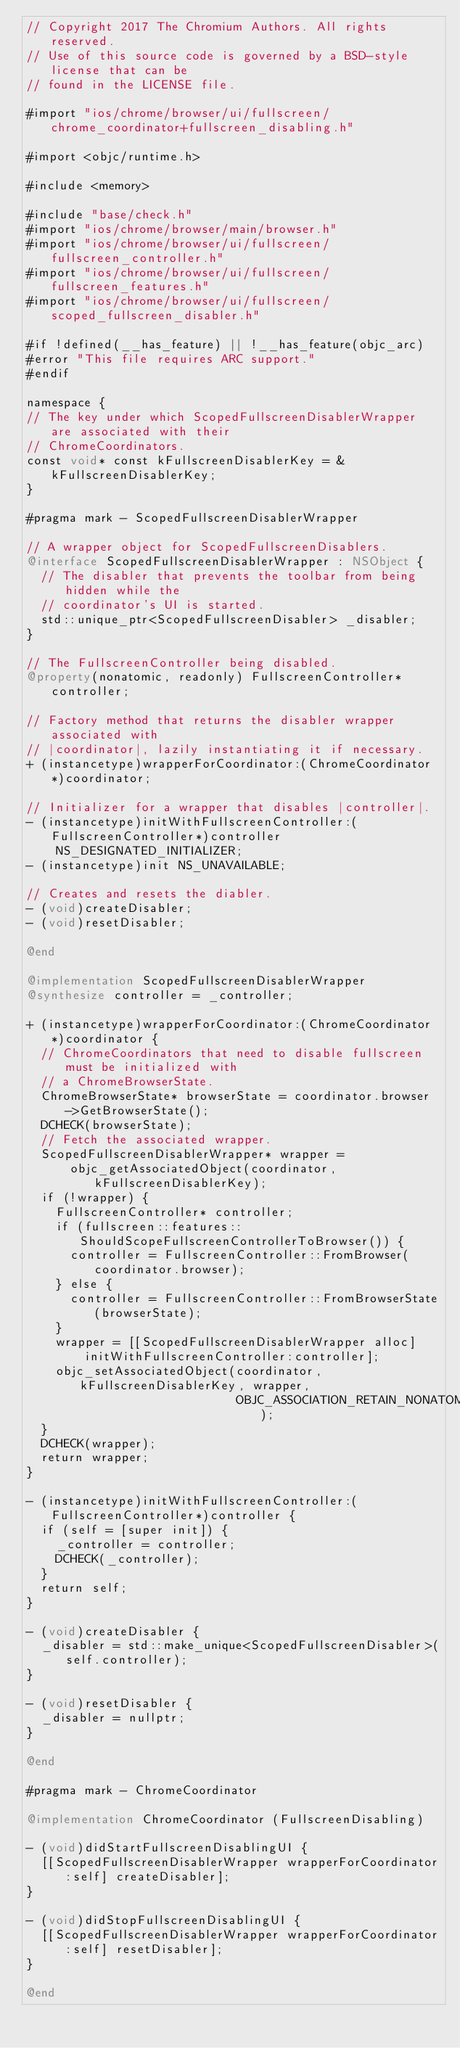Convert code to text. <code><loc_0><loc_0><loc_500><loc_500><_ObjectiveC_>// Copyright 2017 The Chromium Authors. All rights reserved.
// Use of this source code is governed by a BSD-style license that can be
// found in the LICENSE file.

#import "ios/chrome/browser/ui/fullscreen/chrome_coordinator+fullscreen_disabling.h"

#import <objc/runtime.h>

#include <memory>

#include "base/check.h"
#import "ios/chrome/browser/main/browser.h"
#import "ios/chrome/browser/ui/fullscreen/fullscreen_controller.h"
#import "ios/chrome/browser/ui/fullscreen/fullscreen_features.h"
#import "ios/chrome/browser/ui/fullscreen/scoped_fullscreen_disabler.h"

#if !defined(__has_feature) || !__has_feature(objc_arc)
#error "This file requires ARC support."
#endif

namespace {
// The key under which ScopedFullscreenDisablerWrapper are associated with their
// ChromeCoordinators.
const void* const kFullscreenDisablerKey = &kFullscreenDisablerKey;
}

#pragma mark - ScopedFullscreenDisablerWrapper

// A wrapper object for ScopedFullscreenDisablers.
@interface ScopedFullscreenDisablerWrapper : NSObject {
  // The disabler that prevents the toolbar from being hidden while the
  // coordinator's UI is started.
  std::unique_ptr<ScopedFullscreenDisabler> _disabler;
}

// The FullscreenController being disabled.
@property(nonatomic, readonly) FullscreenController* controller;

// Factory method that returns the disabler wrapper associated with
// |coordinator|, lazily instantiating it if necessary.
+ (instancetype)wrapperForCoordinator:(ChromeCoordinator*)coordinator;

// Initializer for a wrapper that disables |controller|.
- (instancetype)initWithFullscreenController:(FullscreenController*)controller
    NS_DESIGNATED_INITIALIZER;
- (instancetype)init NS_UNAVAILABLE;

// Creates and resets the diabler.
- (void)createDisabler;
- (void)resetDisabler;

@end

@implementation ScopedFullscreenDisablerWrapper
@synthesize controller = _controller;

+ (instancetype)wrapperForCoordinator:(ChromeCoordinator*)coordinator {
  // ChromeCoordinators that need to disable fullscreen must be initialized with
  // a ChromeBrowserState.
  ChromeBrowserState* browserState = coordinator.browser->GetBrowserState();
  DCHECK(browserState);
  // Fetch the associated wrapper.
  ScopedFullscreenDisablerWrapper* wrapper =
      objc_getAssociatedObject(coordinator, kFullscreenDisablerKey);
  if (!wrapper) {
    FullscreenController* controller;
    if (fullscreen::features::ShouldScopeFullscreenControllerToBrowser()) {
      controller = FullscreenController::FromBrowser(coordinator.browser);
    } else {
      controller = FullscreenController::FromBrowserState(browserState);
    }
    wrapper = [[ScopedFullscreenDisablerWrapper alloc]
        initWithFullscreenController:controller];
    objc_setAssociatedObject(coordinator, kFullscreenDisablerKey, wrapper,
                             OBJC_ASSOCIATION_RETAIN_NONATOMIC);
  }
  DCHECK(wrapper);
  return wrapper;
}

- (instancetype)initWithFullscreenController:(FullscreenController*)controller {
  if (self = [super init]) {
    _controller = controller;
    DCHECK(_controller);
  }
  return self;
}

- (void)createDisabler {
  _disabler = std::make_unique<ScopedFullscreenDisabler>(self.controller);
}

- (void)resetDisabler {
  _disabler = nullptr;
}

@end

#pragma mark - ChromeCoordinator

@implementation ChromeCoordinator (FullscreenDisabling)

- (void)didStartFullscreenDisablingUI {
  [[ScopedFullscreenDisablerWrapper wrapperForCoordinator:self] createDisabler];
}

- (void)didStopFullscreenDisablingUI {
  [[ScopedFullscreenDisablerWrapper wrapperForCoordinator:self] resetDisabler];
}

@end
</code> 